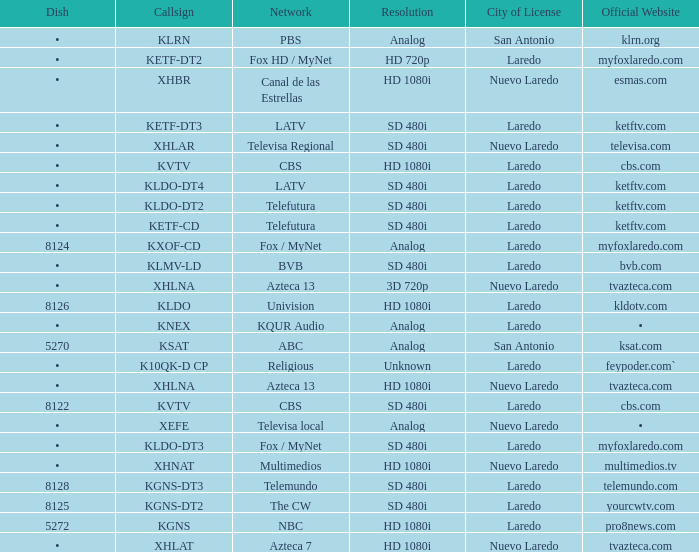Name the resolution with dish of 8126 HD 1080i. 